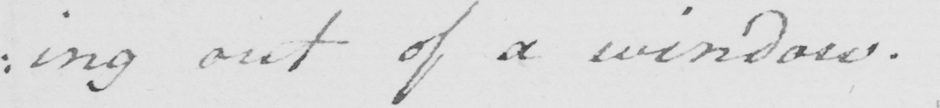Transcribe the text shown in this historical manuscript line. : ing out of a window . 